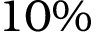Convert formula to latex. <formula><loc_0><loc_0><loc_500><loc_500>1 0 \%</formula> 